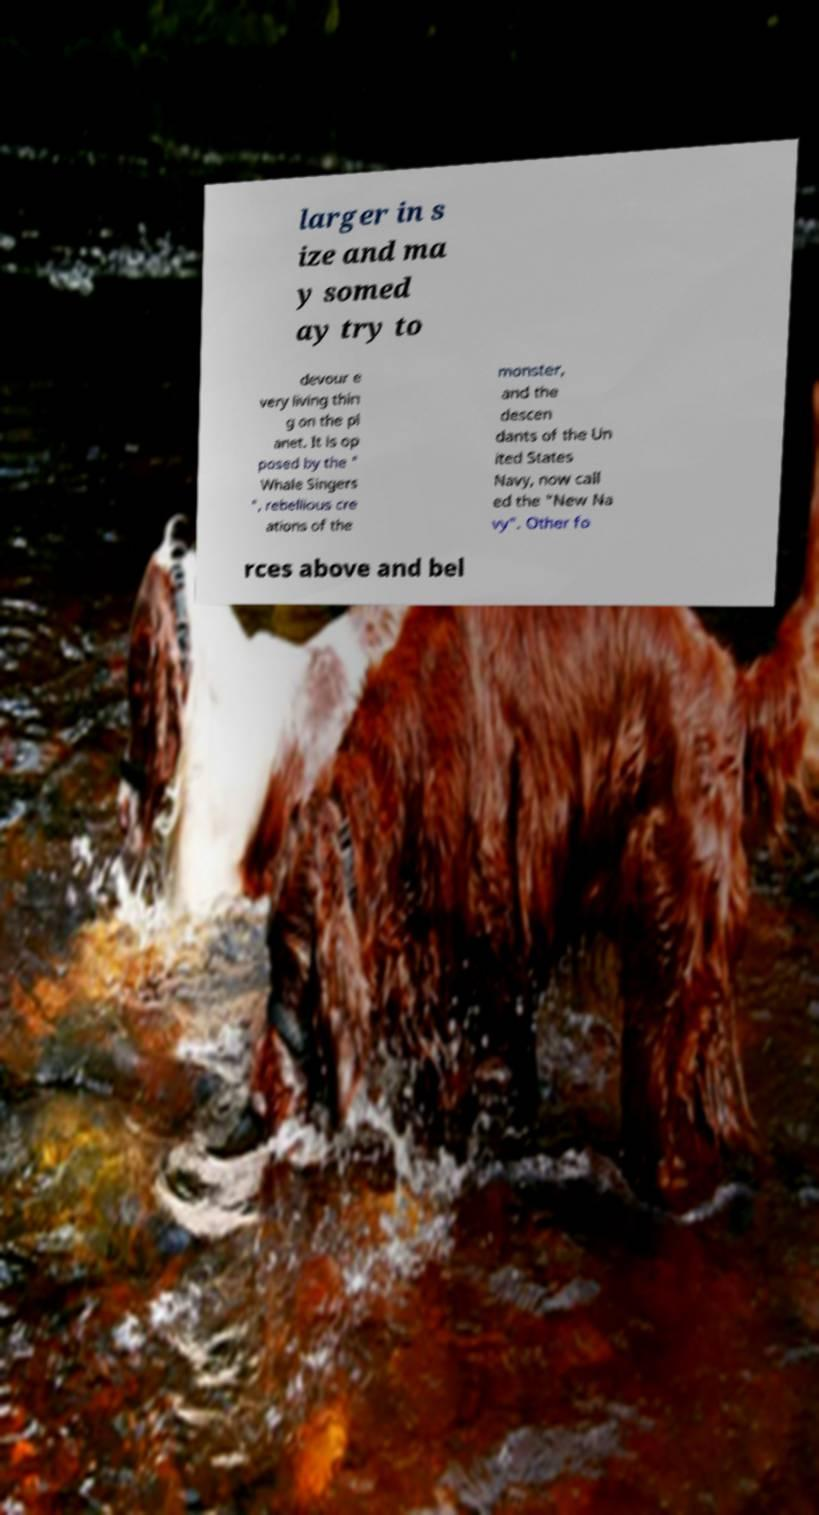Please identify and transcribe the text found in this image. larger in s ize and ma y somed ay try to devour e very living thin g on the pl anet. It is op posed by the " Whale Singers ", rebellious cre ations of the monster, and the descen dants of the Un ited States Navy, now call ed the "New Na vy". Other fo rces above and bel 